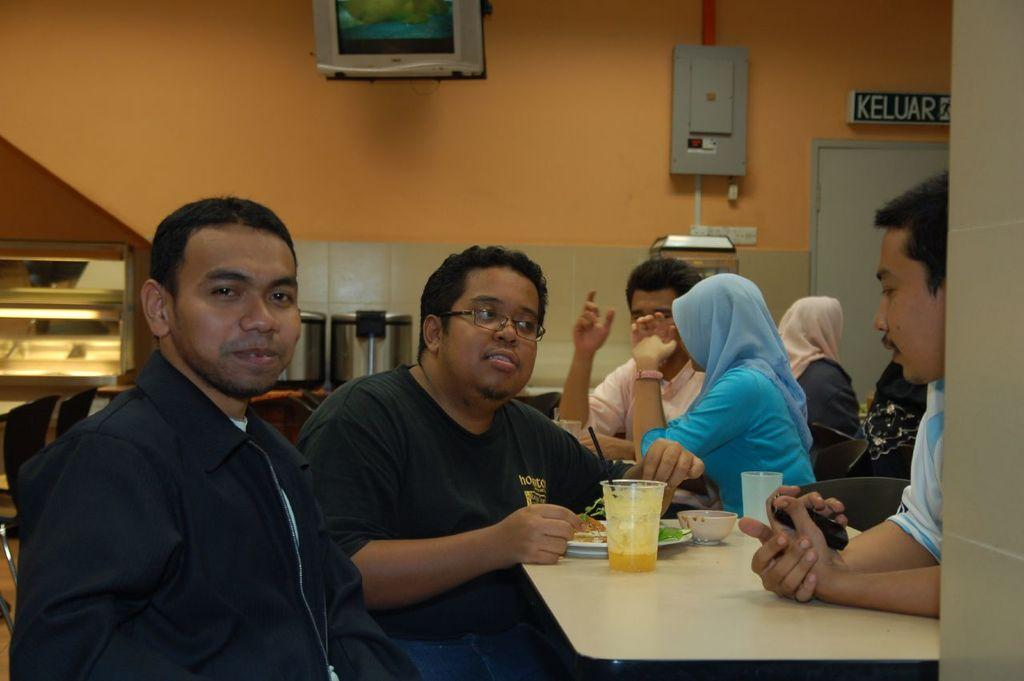What are the people in the image doing? The persons sitting around the tables are likely eating or socializing. What items can be seen on the tables? Glasses, plates, and food are present on the tables. Can you describe the background of the image? In the background, there are persons, a door, a television, and a wall. What type of science experiment is being conducted on the table? There is no science experiment present in the image; it features people sitting around tables with glasses, plates, and food. How many tomatoes are visible on the table? There is no tomato present in the image. What type of berry can be seen on the table? There is no berry present in the image. 